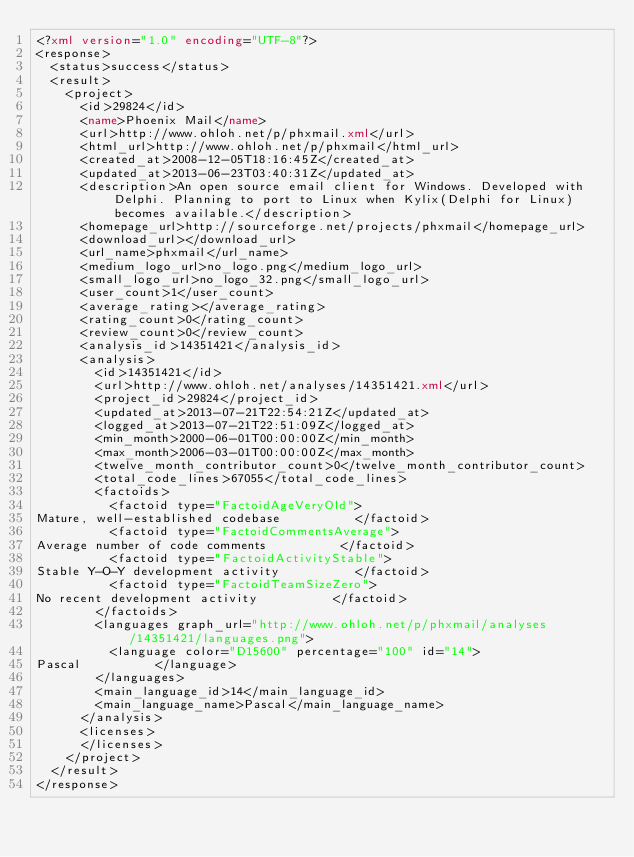<code> <loc_0><loc_0><loc_500><loc_500><_XML_><?xml version="1.0" encoding="UTF-8"?>
<response>
  <status>success</status>
  <result>
    <project>
      <id>29824</id>
      <name>Phoenix Mail</name>
      <url>http://www.ohloh.net/p/phxmail.xml</url>
      <html_url>http://www.ohloh.net/p/phxmail</html_url>
      <created_at>2008-12-05T18:16:45Z</created_at>
      <updated_at>2013-06-23T03:40:31Z</updated_at>
      <description>An open source email client for Windows. Developed with Delphi. Planning to port to Linux when Kylix(Delphi for Linux) becomes available.</description>
      <homepage_url>http://sourceforge.net/projects/phxmail</homepage_url>
      <download_url></download_url>
      <url_name>phxmail</url_name>
      <medium_logo_url>no_logo.png</medium_logo_url>
      <small_logo_url>no_logo_32.png</small_logo_url>
      <user_count>1</user_count>
      <average_rating></average_rating>
      <rating_count>0</rating_count>
      <review_count>0</review_count>
      <analysis_id>14351421</analysis_id>
      <analysis>
        <id>14351421</id>
        <url>http://www.ohloh.net/analyses/14351421.xml</url>
        <project_id>29824</project_id>
        <updated_at>2013-07-21T22:54:21Z</updated_at>
        <logged_at>2013-07-21T22:51:09Z</logged_at>
        <min_month>2000-06-01T00:00:00Z</min_month>
        <max_month>2006-03-01T00:00:00Z</max_month>
        <twelve_month_contributor_count>0</twelve_month_contributor_count>
        <total_code_lines>67055</total_code_lines>
        <factoids>
          <factoid type="FactoidAgeVeryOld">
Mature, well-established codebase          </factoid>
          <factoid type="FactoidCommentsAverage">
Average number of code comments          </factoid>
          <factoid type="FactoidActivityStable">
Stable Y-O-Y development activity          </factoid>
          <factoid type="FactoidTeamSizeZero">
No recent development activity          </factoid>
        </factoids>
        <languages graph_url="http://www.ohloh.net/p/phxmail/analyses/14351421/languages.png">
          <language color="D15600" percentage="100" id="14">
Pascal          </language>
        </languages>
        <main_language_id>14</main_language_id>
        <main_language_name>Pascal</main_language_name>
      </analysis>
      <licenses>
      </licenses>
    </project>
  </result>
</response>
</code> 